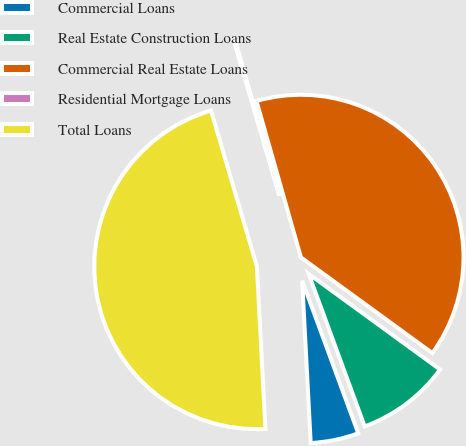<chart> <loc_0><loc_0><loc_500><loc_500><pie_chart><fcel>Commercial Loans<fcel>Real Estate Construction Loans<fcel>Commercial Real Estate Loans<fcel>Residential Mortgage Loans<fcel>Total Loans<nl><fcel>4.77%<fcel>9.38%<fcel>39.42%<fcel>0.15%<fcel>46.28%<nl></chart> 